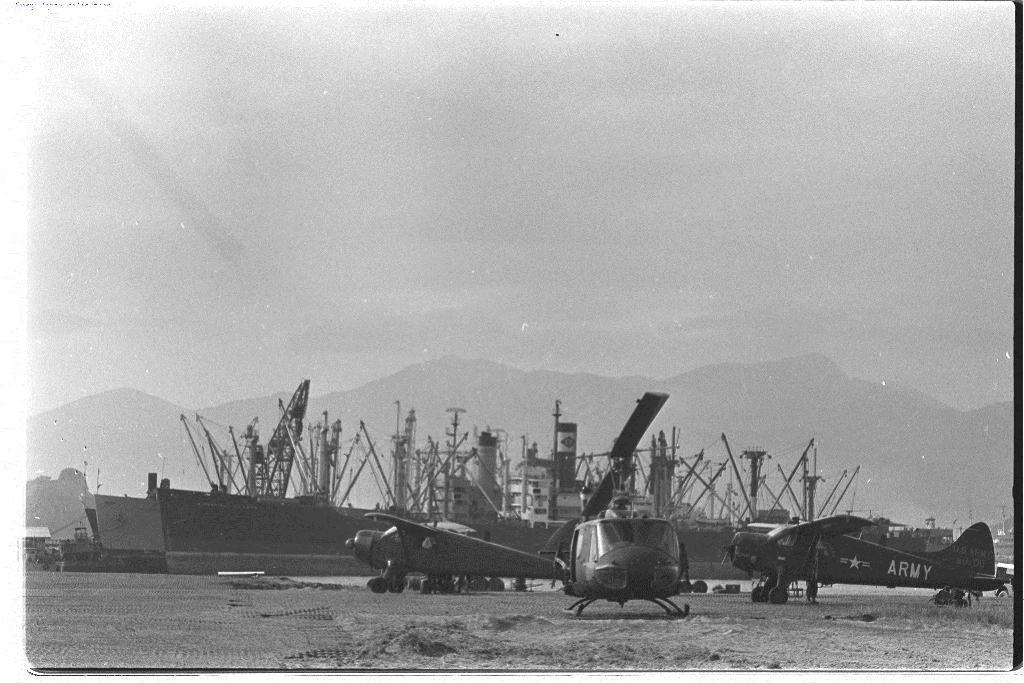Describe this image in one or two sentences. In this picture there are aircrafts at the back there are ships and mountains. This picture is an edited picture. At the top there is sky. 